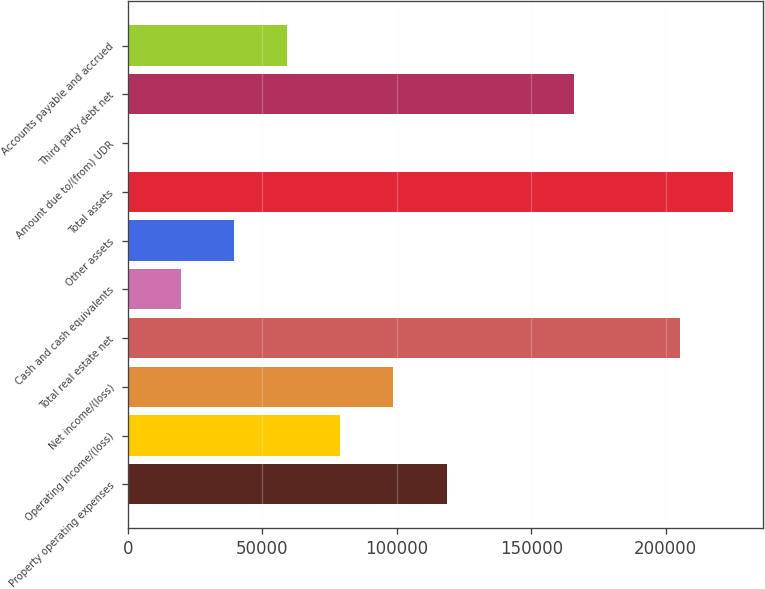Convert chart. <chart><loc_0><loc_0><loc_500><loc_500><bar_chart><fcel>Property operating expenses<fcel>Operating income/(loss)<fcel>Net income/(loss)<fcel>Total real estate net<fcel>Cash and cash equivalents<fcel>Other assets<fcel>Total assets<fcel>Amount due to/(from) UDR<fcel>Third party debt net<fcel>Accounts payable and accrued<nl><fcel>118507<fcel>79081<fcel>98794<fcel>205227<fcel>19942<fcel>39655<fcel>224940<fcel>229<fcel>165801<fcel>59368<nl></chart> 